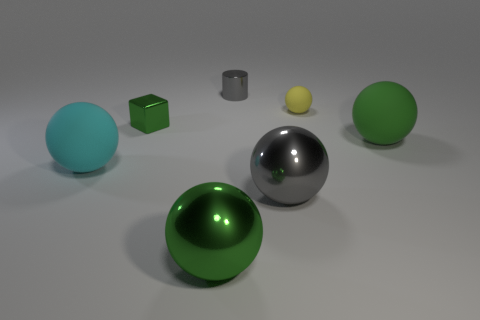Add 3 metal objects. How many objects exist? 10 Subtract all metal spheres. How many spheres are left? 3 Subtract 2 spheres. How many spheres are left? 3 Subtract all gray spheres. How many spheres are left? 4 Subtract all blocks. How many objects are left? 6 Add 1 yellow rubber objects. How many yellow rubber objects are left? 2 Add 1 brown shiny things. How many brown shiny things exist? 1 Subtract 0 red cylinders. How many objects are left? 7 Subtract all blue spheres. Subtract all yellow cylinders. How many spheres are left? 5 Subtract all cyan cubes. How many blue cylinders are left? 0 